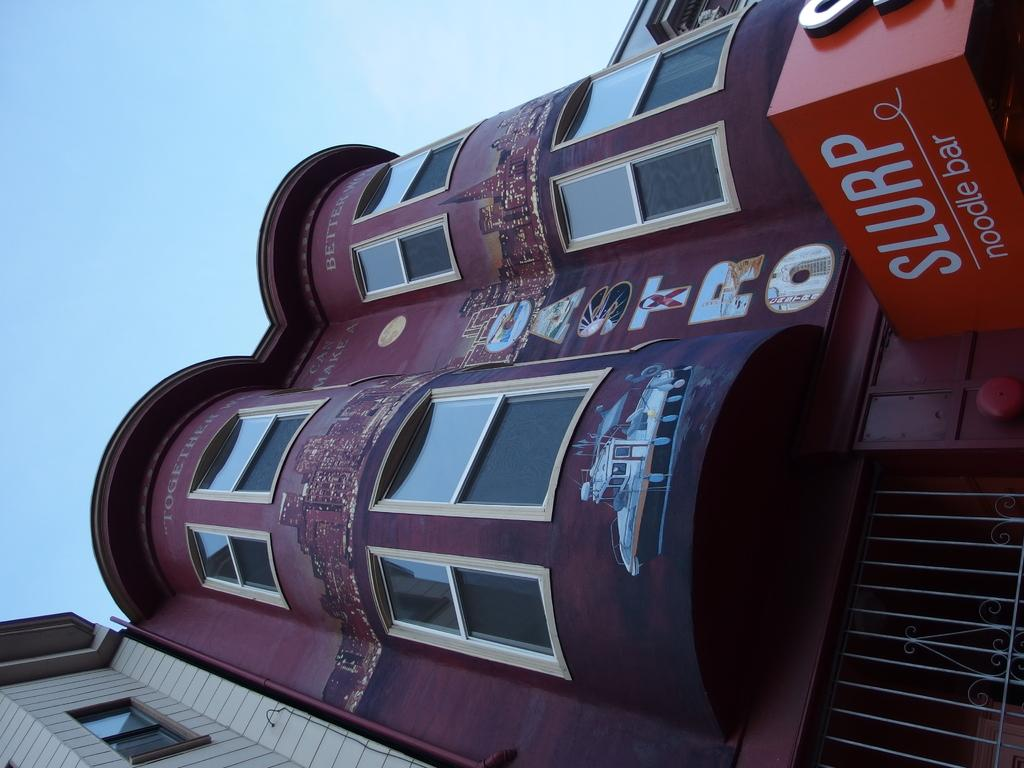What is written on the board in the image? The image contains a board with text, but the specific text is not mentioned in the facts. What type of structures can be seen in the image? There are buildings in the image. What can be seen in the background of the image? The sky is visible in the background of the image. How many birds are perched on the buildings in the image? There is no mention of birds in the image, so we cannot determine the number of birds present. 